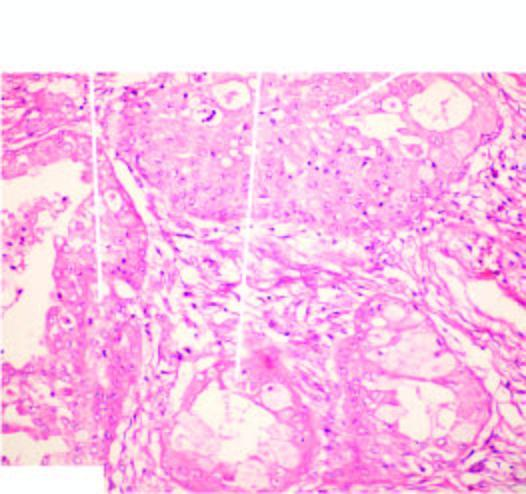does normal bone marrow in an adult show combination of mucinous, squamous and intermediate cells?
Answer the question using a single word or phrase. No 